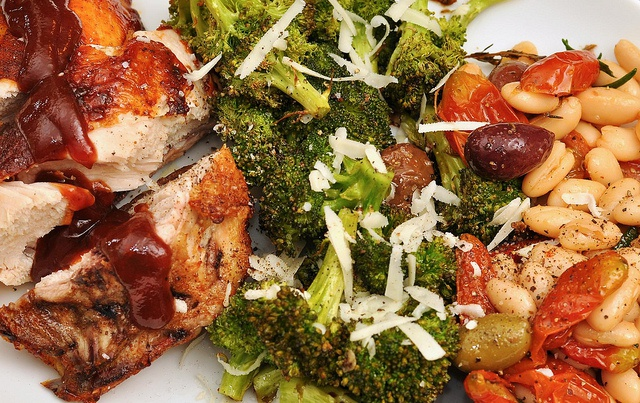Describe the objects in this image and their specific colors. I can see broccoli in maroon, black, olive, and beige tones, broccoli in maroon, black, olive, and beige tones, broccoli in maroon, olive, black, and beige tones, broccoli in maroon, black, and olive tones, and broccoli in maroon, black, and olive tones in this image. 